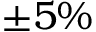<formula> <loc_0><loc_0><loc_500><loc_500>\pm { 5 } \%</formula> 